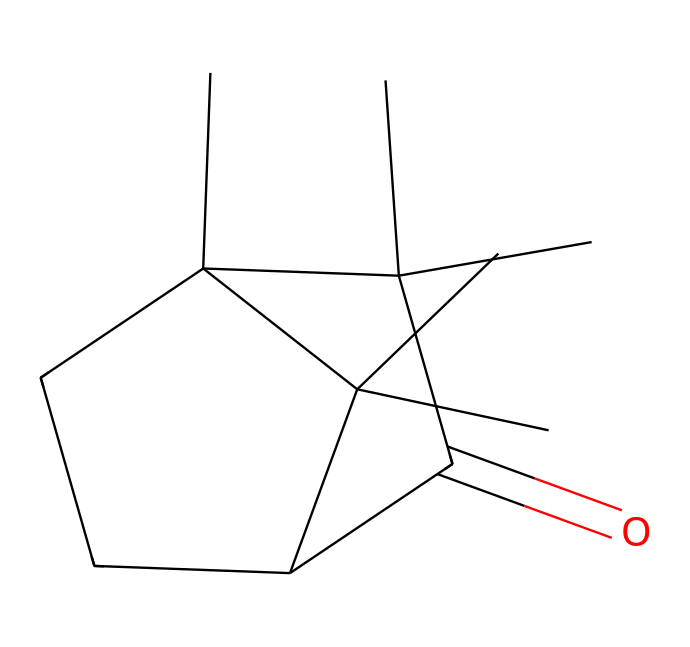What is the functional group present in camphor? The structure of camphor includes a carbonyl group (C=O), which is characteristic of ketones. This specific portion of the molecule indicates the functional group.
Answer: carbonyl How many rings are in the camphor structure? By examining the SMILES representation, we can identify two distinct cycloalkane rings. The notation "C2CCC" indicates a cyclopentane ring, revealing that there are two rings in total.
Answer: 2 What is the molecular formula of camphor? The molecular formula correlates with the number of carbon (C), hydrogen (H), and oxygen (O) atoms derived from the structure. Counting the atoms in the SMILES translates to C10H16O, which represents the entire composition of camphor.
Answer: C10H16O What is the total number of carbon atoms in camphor? Analyzing the SMILES representation, we can see that there are ten carbon atoms present. Each letter "C" in the SMILES indicates a carbon atom, providing the total count directly.
Answer: 10 Is camphor a saturated or unsaturated ketone? The structure of camphor can be evaluated by looking for double bonds. In this case, the presence of a carbonyl group indicates unsaturation, confirming that camphor is an unsaturated ketone.
Answer: unsaturated What type of chemical compound is camphor classified as? By recognizing that camphor contains a ketone functional group and the structure indicates it has both cyclic and acyclic components, we classify this compound as a ketone.
Answer: ketone 